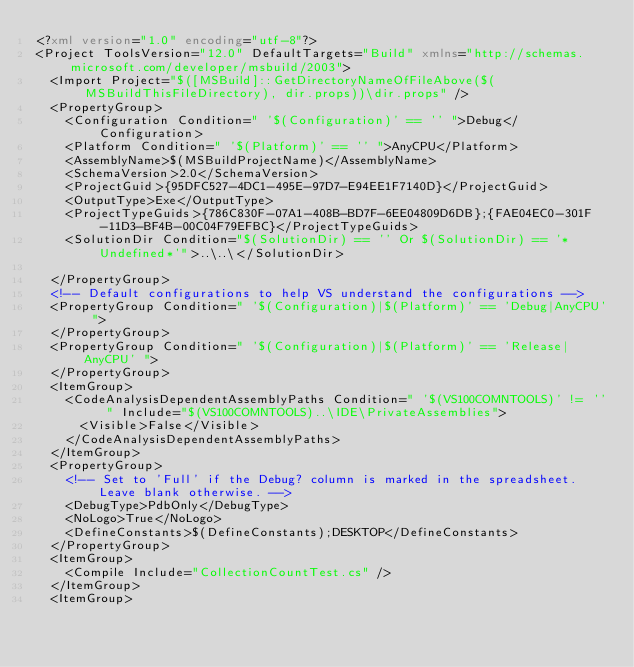<code> <loc_0><loc_0><loc_500><loc_500><_XML_><?xml version="1.0" encoding="utf-8"?>
<Project ToolsVersion="12.0" DefaultTargets="Build" xmlns="http://schemas.microsoft.com/developer/msbuild/2003">
  <Import Project="$([MSBuild]::GetDirectoryNameOfFileAbove($(MSBuildThisFileDirectory), dir.props))\dir.props" />
  <PropertyGroup>
    <Configuration Condition=" '$(Configuration)' == '' ">Debug</Configuration>
    <Platform Condition=" '$(Platform)' == '' ">AnyCPU</Platform>
    <AssemblyName>$(MSBuildProjectName)</AssemblyName>
    <SchemaVersion>2.0</SchemaVersion>
    <ProjectGuid>{95DFC527-4DC1-495E-97D7-E94EE1F7140D}</ProjectGuid>
    <OutputType>Exe</OutputType>
    <ProjectTypeGuids>{786C830F-07A1-408B-BD7F-6EE04809D6DB};{FAE04EC0-301F-11D3-BF4B-00C04F79EFBC}</ProjectTypeGuids>
    <SolutionDir Condition="$(SolutionDir) == '' Or $(SolutionDir) == '*Undefined*'">..\..\</SolutionDir>
    
  </PropertyGroup>
  <!-- Default configurations to help VS understand the configurations -->
  <PropertyGroup Condition=" '$(Configuration)|$(Platform)' == 'Debug|AnyCPU' ">
  </PropertyGroup>
  <PropertyGroup Condition=" '$(Configuration)|$(Platform)' == 'Release|AnyCPU' ">
  </PropertyGroup>
  <ItemGroup>
    <CodeAnalysisDependentAssemblyPaths Condition=" '$(VS100COMNTOOLS)' != '' " Include="$(VS100COMNTOOLS)..\IDE\PrivateAssemblies">
      <Visible>False</Visible>
    </CodeAnalysisDependentAssemblyPaths>
  </ItemGroup>
  <PropertyGroup>
    <!-- Set to 'Full' if the Debug? column is marked in the spreadsheet. Leave blank otherwise. -->
    <DebugType>PdbOnly</DebugType>
    <NoLogo>True</NoLogo>
    <DefineConstants>$(DefineConstants);DESKTOP</DefineConstants>
  </PropertyGroup>
  <ItemGroup>
    <Compile Include="CollectionCountTest.cs" />
  </ItemGroup>
  <ItemGroup></code> 